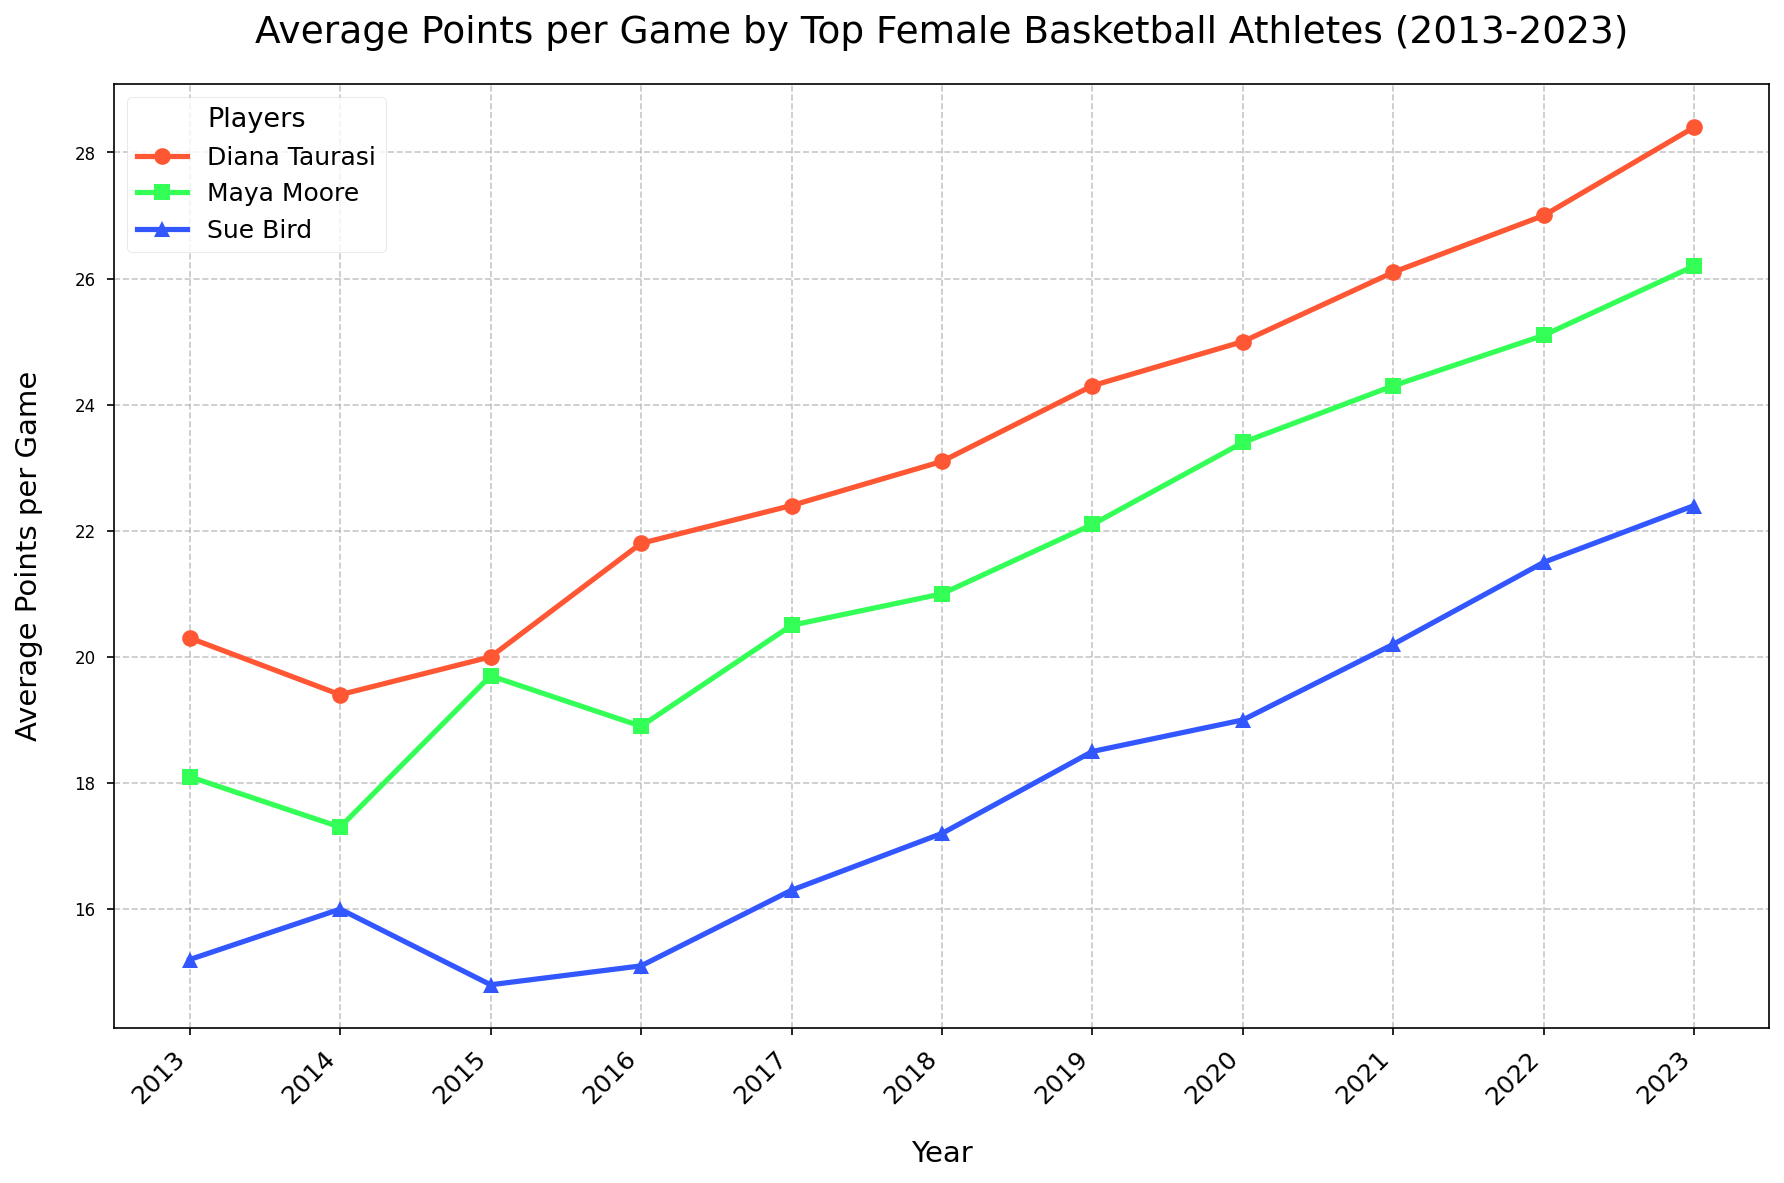Which player scored the highest average points per game in 2023? By looking at the 2023 data points, the highest average points per game corresponds to Diana Taurasi.
Answer: Diana Taurasi How did Sue Bird's average points per game change from 2013 to 2023? Sue Bird's average points per game in 2013 was 15.2 and increased to 22.4 in 2023. To determine the change, subtract 15.2 from 22.4.
Answer: Increased by 7.2 points Which years did Maya Moore's average points per game increase? By following Maya Moore's line from 2013 to 2023, her average points per game increased each year without any decline.
Answer: Every year Which player had the lowest average points per game in 2015? Looking at the data points for 2015, Sue Bird had the lowest average points per game among the three players.
Answer: Sue Bird During which years did Diana Taurasi's average points per game exceed 25? Observing Diana Taurasi's line, her average points per game exceeded 25 in 2020, 2021, 2022, and 2023.
Answer: 2020, 2021, 2022, 2023 How many times did the average points per game of Maya Moore surpass 20? By identifying Maya Moore's data points, her average points per game surpassed 20 in 2017, 2018, 2019, 2020, 2021, 2022, and 2023.
Answer: 7 times Which player showed the most significant increase in average points per game over the 10-year period? Comparing the lines, Diana Taurasi increased from 20.3 in 2013 to 28.4 in 2023, representing the most significant increase.
Answer: Diana Taurasi When did Sue Bird's average points per game first exceed 18? Tracking Sue Bird's line, her average points per game first exceeded 18 in 2019.
Answer: 2019 What is the difference between Maya Moore's and Sue Bird's average points per game in 2023? Maya Moore scored 26.2 points, and Sue Bird scored 22.4 points. The difference is 26.2 - 22.4.
Answer: 3.8 points Which year shows the steepest increase in Diana Taurasi's average points per game? By analyzing Diana Taurasi's line, the steepest increase occurred from 2022 to 2023, where it jumped from 27.0 to 28.4 points.
Answer: 2022 to 2023 